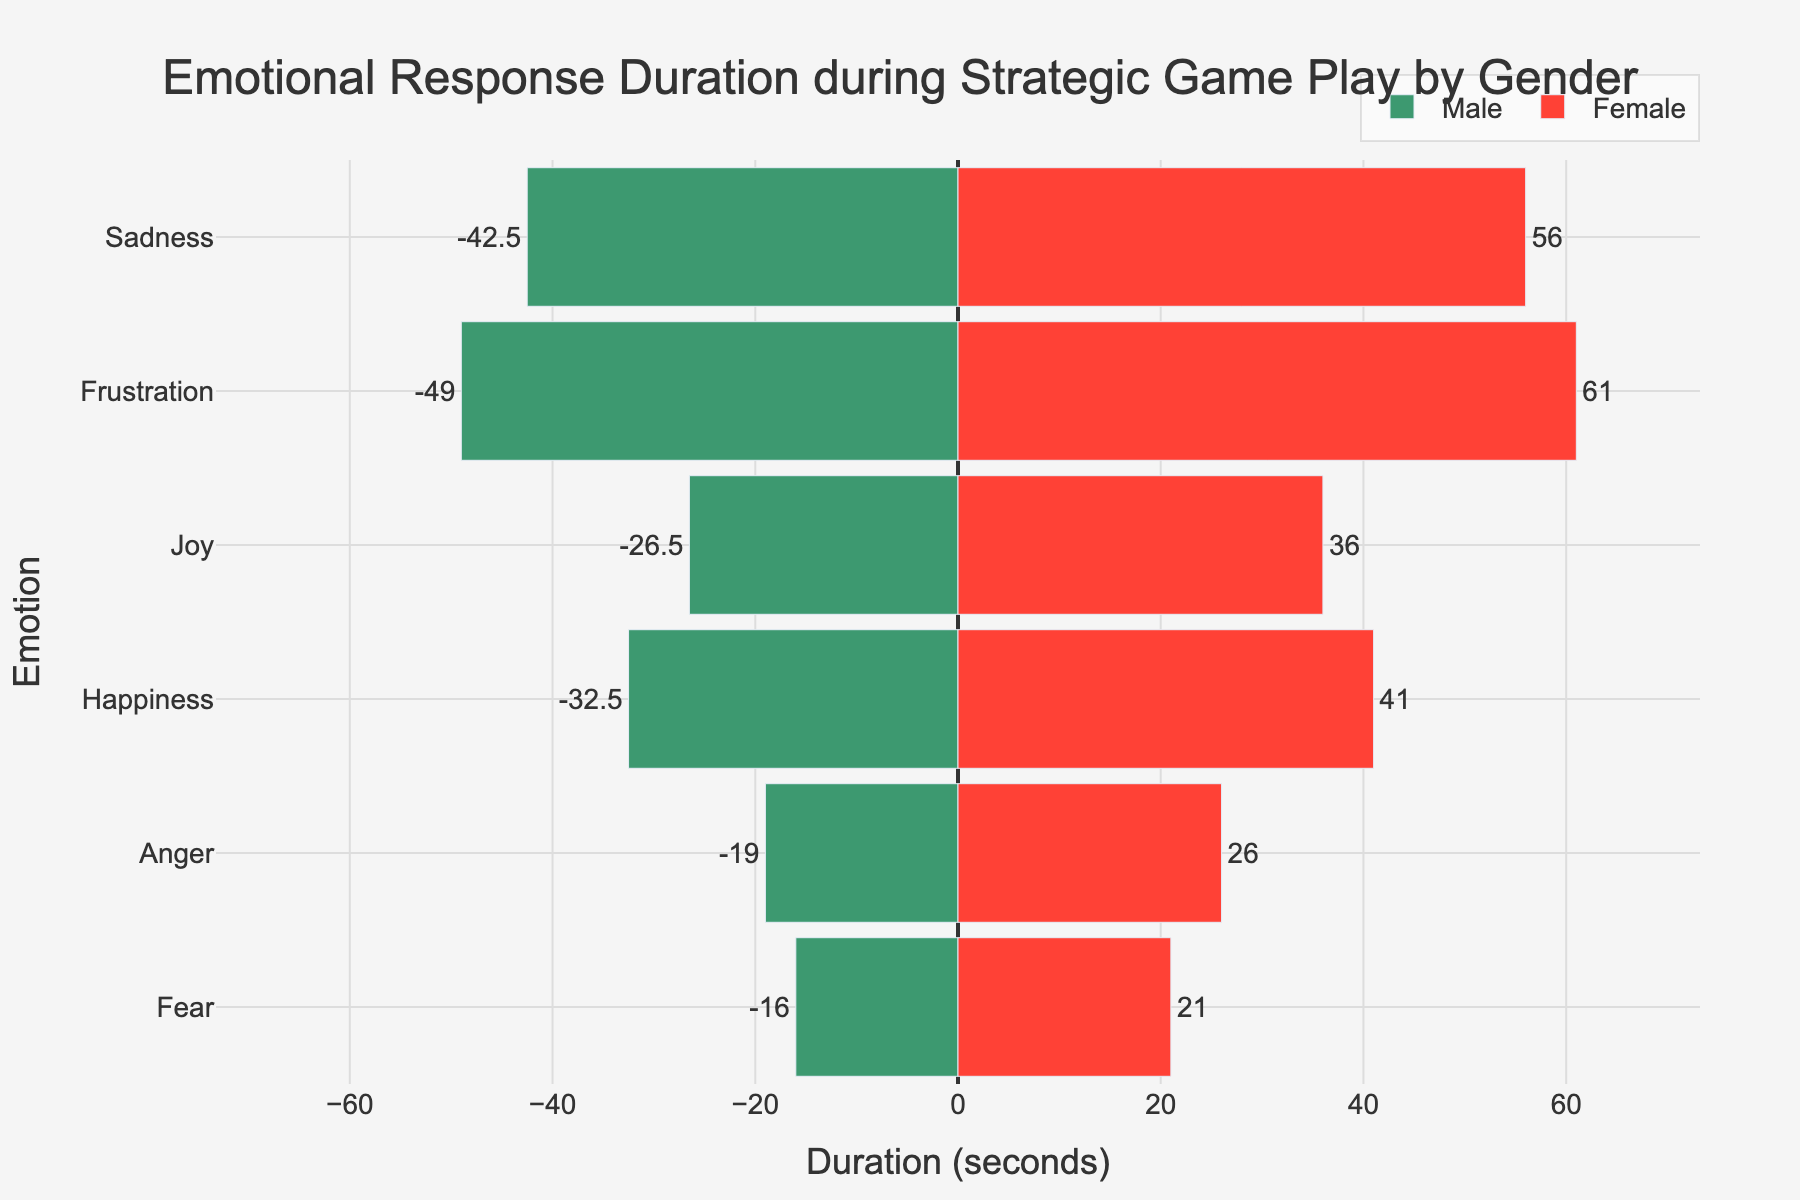what is the average duration of sadness for males and females combined? First, obtain the average durations for males and females separately. For males, the average is (40 + 45) / 2 = 42.5 seconds. For females, the average is (55 + 57) / 2 = 56 seconds. Now, add the two averages together and divide by 2. That gives (42.5 + 56) / 2 = 49.25 seconds.
Answer: 49.25 seconds Which gender experiences Frustration for a longer duration? From the chart, the bar for female Frustration is longer than that for males. Specifically, females have an average duration of 61 seconds, whereas males have an average of 49 seconds. Thus, females experience Frustration for a longer duration.
Answer: Female By how many seconds is the average duration of Anger higher in females compared to males? The average duration of Anger for males is (20 + 18) / 2 = 19 seconds. For females, it is (25 + 27) / 2 = 26 seconds. Subtract the male average from the female average, which is 26 - 19 = 7 seconds.
Answer: 7 seconds How many seconds longer do females experience Joy compared to males? The average duration of Joy for males is (28 + 25) / 2 = 26.5 seconds. For females, it is (35 + 37) / 2 = 36 seconds. Subtract the male average from the female average, which gives 36 - 26.5 = 9.5 seconds.
Answer: 9.5 seconds Which emotion has the smallest difference in duration between male and female experiences? From the chart, we can see that Fear has the smallest difference when comparing bar lengths. Specifically, males have an average of 16 seconds, and females have an average of 21 seconds, giving a difference of 5 seconds.
Answer: Fear What is the total duration (sum) of Happiness and Joy experienced by males? The average duration for Happiness is (35 + 30) / 2 = 32.5 seconds, and for Joy, it is (28 + 25) / 2 = 26.5 seconds. Sum these averages to get 32.5 + 26.5 = 59 seconds.
Answer: 59 seconds How does the duration of Sadness in females compare to the duration of Fear in males? The average duration of Sadness for females is (55 + 57) / 2 = 56 seconds. For males, the average duration of Fear is (15 + 17) / 2 = 16 seconds. Females experience Sadness much longer than males experience Fear.
Answer: Females experience Sadness much longer What emotion has the highest average duration for females? Looking at the chart, the bar for Frustration is the highest for females, with an average duration of 61 seconds.
Answer: Frustration What's the difference in the duration of Frustration between genders in seconds? The average duration of Frustration for males is (50 + 48) / 2 = 49 seconds, and for females, it is (60 + 62) / 2 = 61 seconds. The difference is 61 - 49 = 12 seconds.
Answer: 12 seconds 